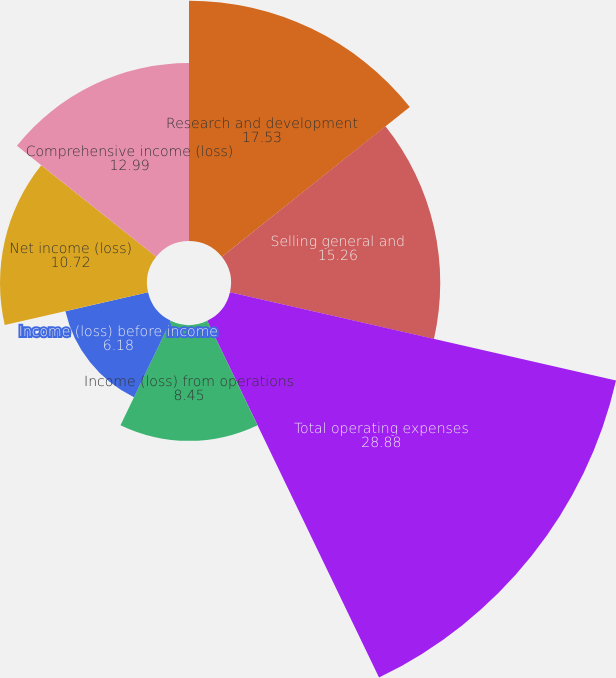Convert chart. <chart><loc_0><loc_0><loc_500><loc_500><pie_chart><fcel>Research and development<fcel>Selling general and<fcel>Total operating expenses<fcel>Income (loss) from operations<fcel>Income (loss) before income<fcel>Net income (loss)<fcel>Comprehensive income (loss)<nl><fcel>17.53%<fcel>15.26%<fcel>28.88%<fcel>8.45%<fcel>6.18%<fcel>10.72%<fcel>12.99%<nl></chart> 